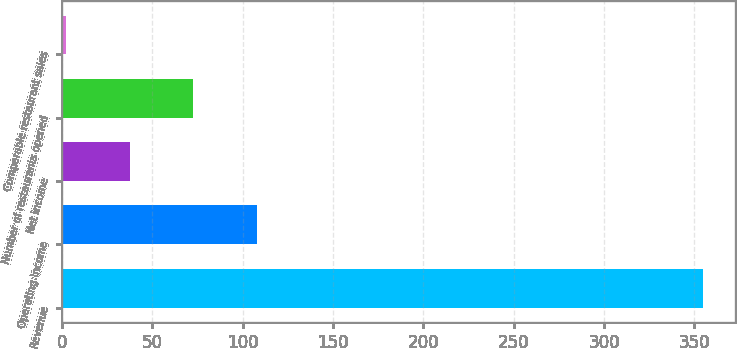Convert chart. <chart><loc_0><loc_0><loc_500><loc_500><bar_chart><fcel>Revenue<fcel>Operating income<fcel>Net income<fcel>Number of restaurants opened<fcel>Comparable restaurant sales<nl><fcel>354.5<fcel>107.89<fcel>37.43<fcel>72.66<fcel>2.2<nl></chart> 